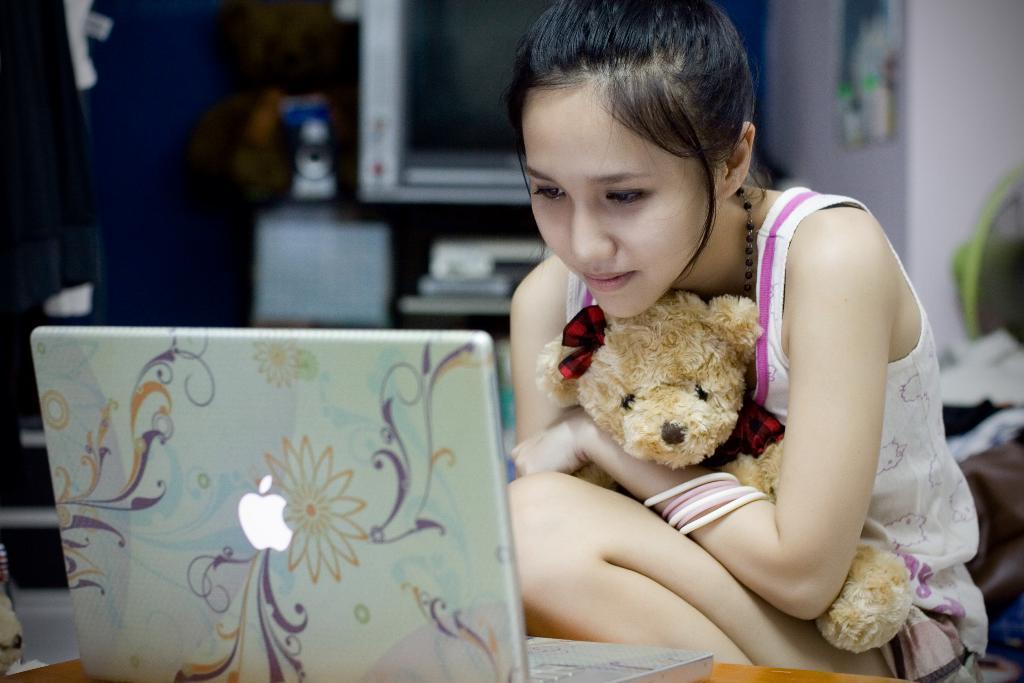Describe this image in one or two sentences. In this picture we can see a girl,she is holding a teddy bear,in front of her we can see a laptop and in the background we can see some objects. 